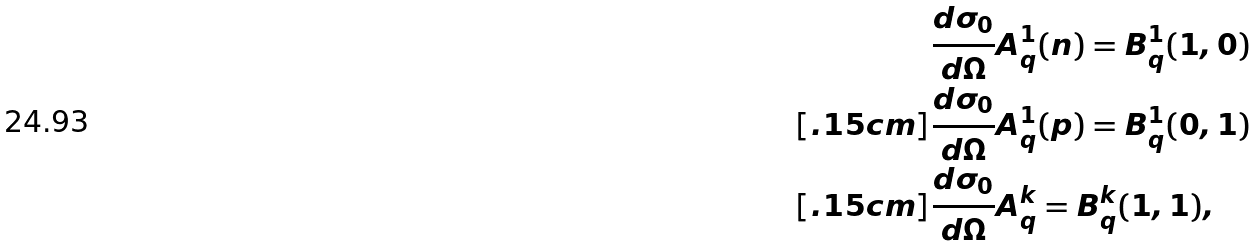<formula> <loc_0><loc_0><loc_500><loc_500>& \frac { d \sigma _ { 0 } } { d \Omega } A ^ { 1 } _ { q } ( n ) = B ^ { 1 } _ { q } ( 1 , 0 ) \\ [ . 1 5 c m ] & \frac { d \sigma _ { 0 } } { d \Omega } A ^ { 1 } _ { q } ( p ) = B ^ { 1 } _ { q } ( 0 , 1 ) \\ [ . 1 5 c m ] & \frac { d \sigma _ { 0 } } { d \Omega } A ^ { k } _ { q } = B ^ { k } _ { q } ( 1 , 1 ) ,</formula> 